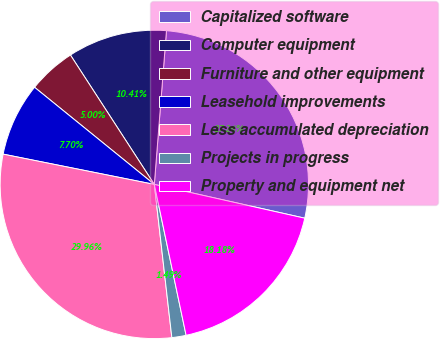Convert chart. <chart><loc_0><loc_0><loc_500><loc_500><pie_chart><fcel>Capitalized software<fcel>Computer equipment<fcel>Furniture and other equipment<fcel>Leasehold improvements<fcel>Less accumulated depreciation<fcel>Projects in progress<fcel>Property and equipment net<nl><fcel>27.26%<fcel>10.41%<fcel>5.0%<fcel>7.7%<fcel>29.96%<fcel>1.49%<fcel>18.18%<nl></chart> 